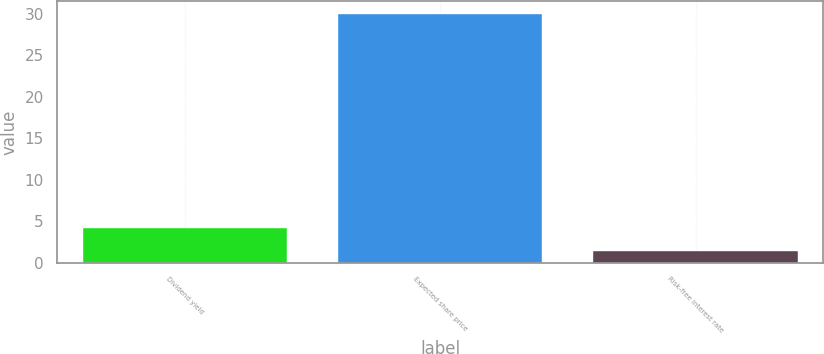<chart> <loc_0><loc_0><loc_500><loc_500><bar_chart><fcel>Dividend yield<fcel>Expected share price<fcel>Risk-free interest rate<nl><fcel>4.21<fcel>30<fcel>1.34<nl></chart> 